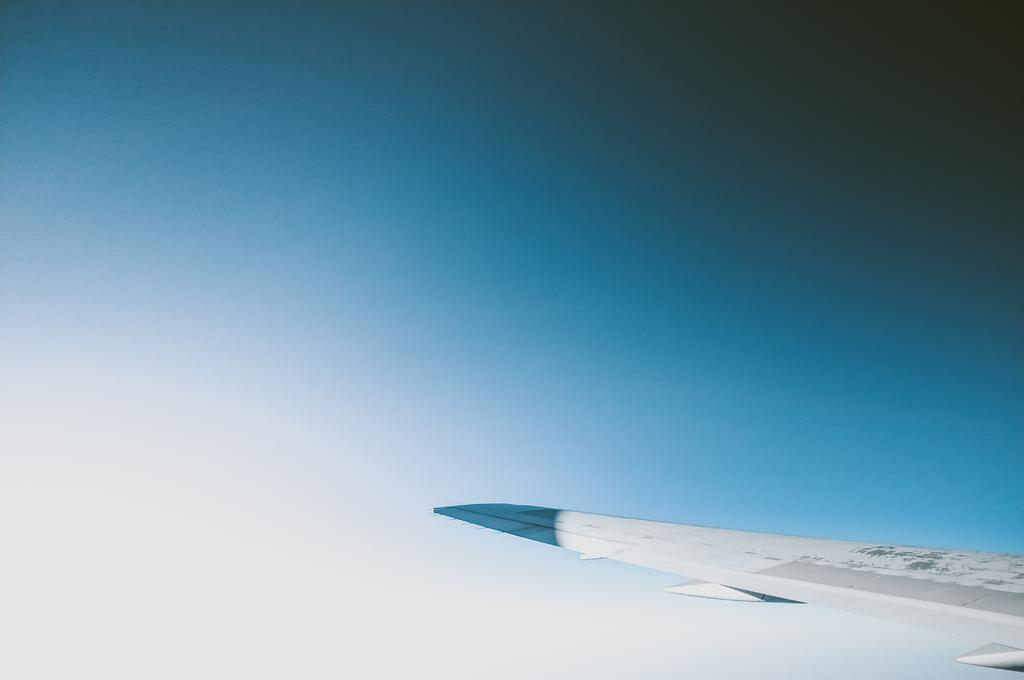What is the main subject of the image? The main subject of the image is an aircraft wing. What can be seen in the background of the image? The sky is visible in the background of the image. What type of food is being served on the spoon in the image? There is no spoon present in the image, as it features an aircraft wing and the sky in the background. 